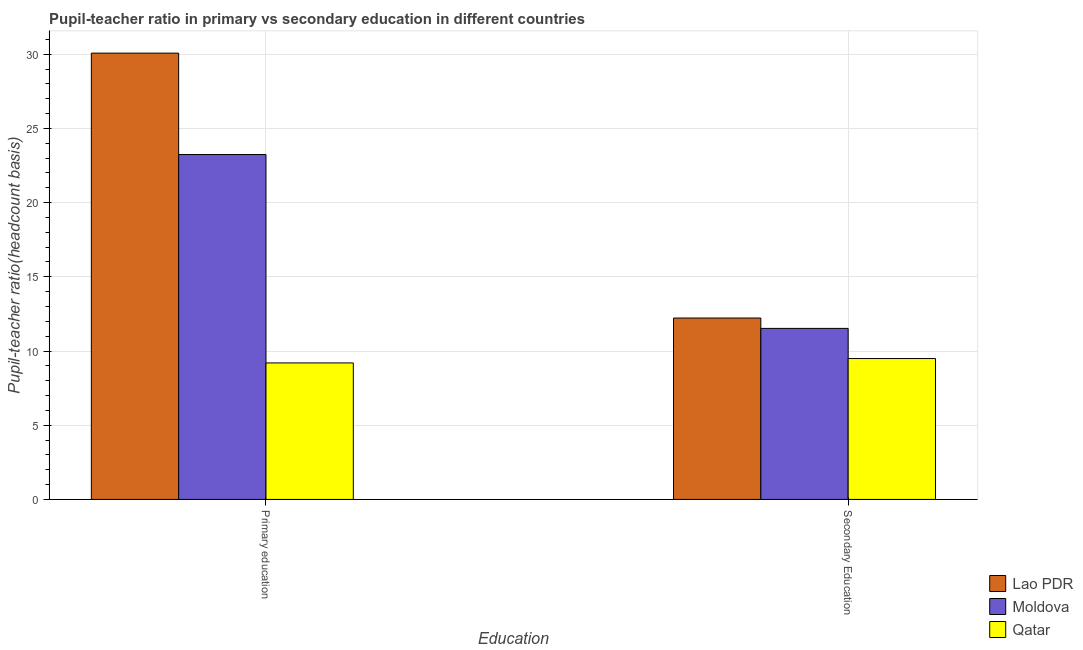How many groups of bars are there?
Ensure brevity in your answer.  2. Are the number of bars on each tick of the X-axis equal?
Ensure brevity in your answer.  Yes. How many bars are there on the 2nd tick from the left?
Ensure brevity in your answer.  3. What is the label of the 2nd group of bars from the left?
Offer a terse response. Secondary Education. What is the pupil-teacher ratio in primary education in Lao PDR?
Your response must be concise. 30.07. Across all countries, what is the maximum pupil teacher ratio on secondary education?
Keep it short and to the point. 12.22. Across all countries, what is the minimum pupil teacher ratio on secondary education?
Provide a short and direct response. 9.49. In which country was the pupil-teacher ratio in primary education maximum?
Provide a short and direct response. Lao PDR. In which country was the pupil teacher ratio on secondary education minimum?
Provide a short and direct response. Qatar. What is the total pupil teacher ratio on secondary education in the graph?
Offer a terse response. 33.24. What is the difference between the pupil teacher ratio on secondary education in Qatar and that in Moldova?
Offer a terse response. -2.03. What is the difference between the pupil teacher ratio on secondary education in Moldova and the pupil-teacher ratio in primary education in Qatar?
Your answer should be very brief. 2.33. What is the average pupil-teacher ratio in primary education per country?
Give a very brief answer. 20.83. What is the difference between the pupil-teacher ratio in primary education and pupil teacher ratio on secondary education in Lao PDR?
Provide a succinct answer. 17.85. In how many countries, is the pupil-teacher ratio in primary education greater than 6 ?
Ensure brevity in your answer.  3. What is the ratio of the pupil teacher ratio on secondary education in Moldova to that in Qatar?
Make the answer very short. 1.21. Is the pupil teacher ratio on secondary education in Qatar less than that in Moldova?
Your answer should be compact. Yes. In how many countries, is the pupil-teacher ratio in primary education greater than the average pupil-teacher ratio in primary education taken over all countries?
Offer a very short reply. 2. What does the 1st bar from the left in Primary education represents?
Offer a terse response. Lao PDR. What does the 1st bar from the right in Secondary Education represents?
Provide a short and direct response. Qatar. Are all the bars in the graph horizontal?
Provide a short and direct response. No. Are the values on the major ticks of Y-axis written in scientific E-notation?
Provide a succinct answer. No. Does the graph contain any zero values?
Offer a terse response. No. How many legend labels are there?
Provide a succinct answer. 3. How are the legend labels stacked?
Keep it short and to the point. Vertical. What is the title of the graph?
Offer a terse response. Pupil-teacher ratio in primary vs secondary education in different countries. Does "Lao PDR" appear as one of the legend labels in the graph?
Your response must be concise. Yes. What is the label or title of the X-axis?
Your answer should be very brief. Education. What is the label or title of the Y-axis?
Keep it short and to the point. Pupil-teacher ratio(headcount basis). What is the Pupil-teacher ratio(headcount basis) in Lao PDR in Primary education?
Keep it short and to the point. 30.07. What is the Pupil-teacher ratio(headcount basis) in Moldova in Primary education?
Keep it short and to the point. 23.24. What is the Pupil-teacher ratio(headcount basis) of Qatar in Primary education?
Provide a succinct answer. 9.2. What is the Pupil-teacher ratio(headcount basis) in Lao PDR in Secondary Education?
Ensure brevity in your answer.  12.22. What is the Pupil-teacher ratio(headcount basis) of Moldova in Secondary Education?
Your answer should be very brief. 11.52. What is the Pupil-teacher ratio(headcount basis) in Qatar in Secondary Education?
Offer a terse response. 9.49. Across all Education, what is the maximum Pupil-teacher ratio(headcount basis) in Lao PDR?
Make the answer very short. 30.07. Across all Education, what is the maximum Pupil-teacher ratio(headcount basis) in Moldova?
Ensure brevity in your answer.  23.24. Across all Education, what is the maximum Pupil-teacher ratio(headcount basis) in Qatar?
Give a very brief answer. 9.49. Across all Education, what is the minimum Pupil-teacher ratio(headcount basis) of Lao PDR?
Give a very brief answer. 12.22. Across all Education, what is the minimum Pupil-teacher ratio(headcount basis) of Moldova?
Keep it short and to the point. 11.52. Across all Education, what is the minimum Pupil-teacher ratio(headcount basis) of Qatar?
Provide a short and direct response. 9.2. What is the total Pupil-teacher ratio(headcount basis) in Lao PDR in the graph?
Your response must be concise. 42.29. What is the total Pupil-teacher ratio(headcount basis) in Moldova in the graph?
Provide a succinct answer. 34.76. What is the total Pupil-teacher ratio(headcount basis) of Qatar in the graph?
Your answer should be compact. 18.69. What is the difference between the Pupil-teacher ratio(headcount basis) in Lao PDR in Primary education and that in Secondary Education?
Offer a terse response. 17.85. What is the difference between the Pupil-teacher ratio(headcount basis) in Moldova in Primary education and that in Secondary Education?
Keep it short and to the point. 11.72. What is the difference between the Pupil-teacher ratio(headcount basis) in Qatar in Primary education and that in Secondary Education?
Keep it short and to the point. -0.3. What is the difference between the Pupil-teacher ratio(headcount basis) in Lao PDR in Primary education and the Pupil-teacher ratio(headcount basis) in Moldova in Secondary Education?
Your answer should be compact. 18.55. What is the difference between the Pupil-teacher ratio(headcount basis) in Lao PDR in Primary education and the Pupil-teacher ratio(headcount basis) in Qatar in Secondary Education?
Give a very brief answer. 20.58. What is the difference between the Pupil-teacher ratio(headcount basis) in Moldova in Primary education and the Pupil-teacher ratio(headcount basis) in Qatar in Secondary Education?
Give a very brief answer. 13.75. What is the average Pupil-teacher ratio(headcount basis) in Lao PDR per Education?
Provide a succinct answer. 21.15. What is the average Pupil-teacher ratio(headcount basis) in Moldova per Education?
Your answer should be compact. 17.38. What is the average Pupil-teacher ratio(headcount basis) in Qatar per Education?
Make the answer very short. 9.34. What is the difference between the Pupil-teacher ratio(headcount basis) of Lao PDR and Pupil-teacher ratio(headcount basis) of Moldova in Primary education?
Your answer should be very brief. 6.83. What is the difference between the Pupil-teacher ratio(headcount basis) in Lao PDR and Pupil-teacher ratio(headcount basis) in Qatar in Primary education?
Make the answer very short. 20.87. What is the difference between the Pupil-teacher ratio(headcount basis) in Moldova and Pupil-teacher ratio(headcount basis) in Qatar in Primary education?
Offer a very short reply. 14.04. What is the difference between the Pupil-teacher ratio(headcount basis) in Lao PDR and Pupil-teacher ratio(headcount basis) in Moldova in Secondary Education?
Provide a succinct answer. 0.7. What is the difference between the Pupil-teacher ratio(headcount basis) in Lao PDR and Pupil-teacher ratio(headcount basis) in Qatar in Secondary Education?
Offer a very short reply. 2.73. What is the difference between the Pupil-teacher ratio(headcount basis) in Moldova and Pupil-teacher ratio(headcount basis) in Qatar in Secondary Education?
Your answer should be very brief. 2.03. What is the ratio of the Pupil-teacher ratio(headcount basis) in Lao PDR in Primary education to that in Secondary Education?
Provide a short and direct response. 2.46. What is the ratio of the Pupil-teacher ratio(headcount basis) in Moldova in Primary education to that in Secondary Education?
Provide a short and direct response. 2.02. What is the ratio of the Pupil-teacher ratio(headcount basis) of Qatar in Primary education to that in Secondary Education?
Offer a terse response. 0.97. What is the difference between the highest and the second highest Pupil-teacher ratio(headcount basis) in Lao PDR?
Your answer should be very brief. 17.85. What is the difference between the highest and the second highest Pupil-teacher ratio(headcount basis) of Moldova?
Offer a very short reply. 11.72. What is the difference between the highest and the second highest Pupil-teacher ratio(headcount basis) of Qatar?
Offer a terse response. 0.3. What is the difference between the highest and the lowest Pupil-teacher ratio(headcount basis) in Lao PDR?
Offer a terse response. 17.85. What is the difference between the highest and the lowest Pupil-teacher ratio(headcount basis) in Moldova?
Give a very brief answer. 11.72. What is the difference between the highest and the lowest Pupil-teacher ratio(headcount basis) in Qatar?
Your answer should be compact. 0.3. 